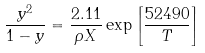<formula> <loc_0><loc_0><loc_500><loc_500>\frac { y ^ { 2 } } { 1 - y } = \frac { 2 . 1 1 } { \rho X } \exp \left [ { \frac { 5 2 4 9 0 } { T } } \right ]</formula> 